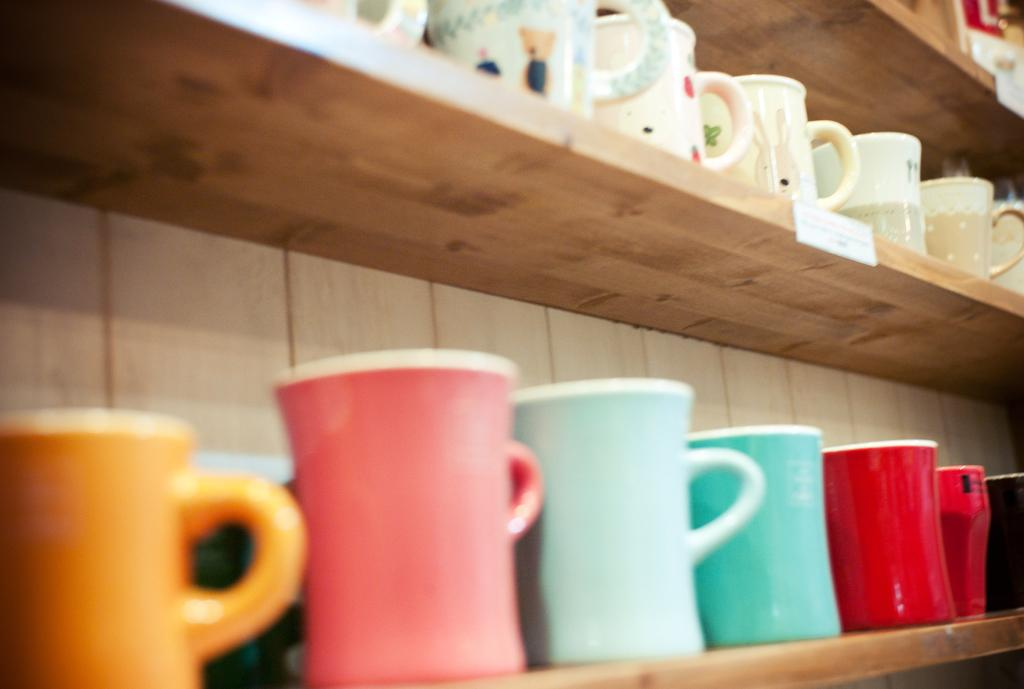What can be seen in the image? There is a rack in the image. What is placed on the rack? Mugs are placed in the rack. What type of throat is visible in the image? There is no throat visible in the image; it only features a rack with mugs. 